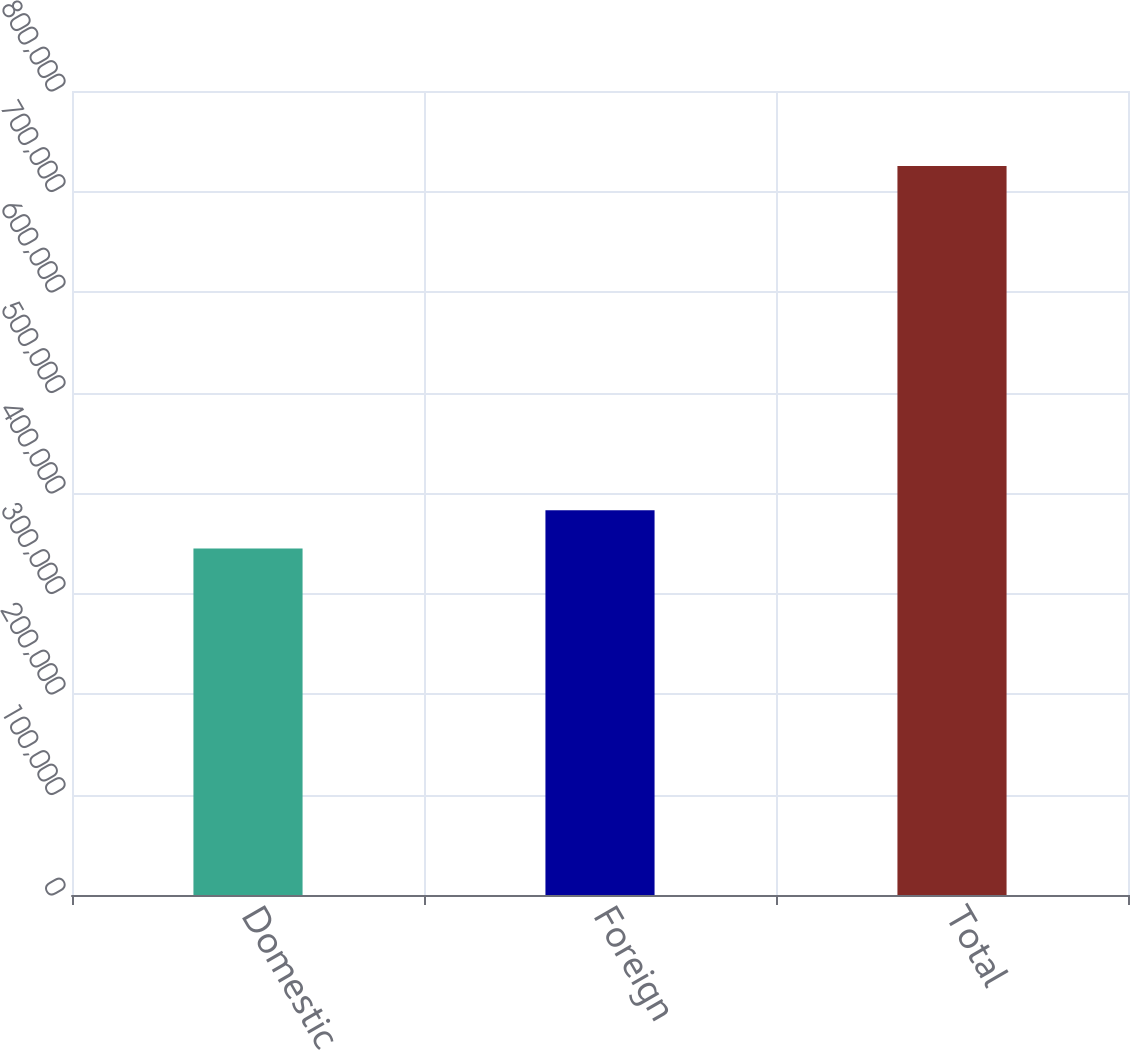Convert chart to OTSL. <chart><loc_0><loc_0><loc_500><loc_500><bar_chart><fcel>Domestic<fcel>Foreign<fcel>Total<nl><fcel>344793<fcel>382852<fcel>725378<nl></chart> 